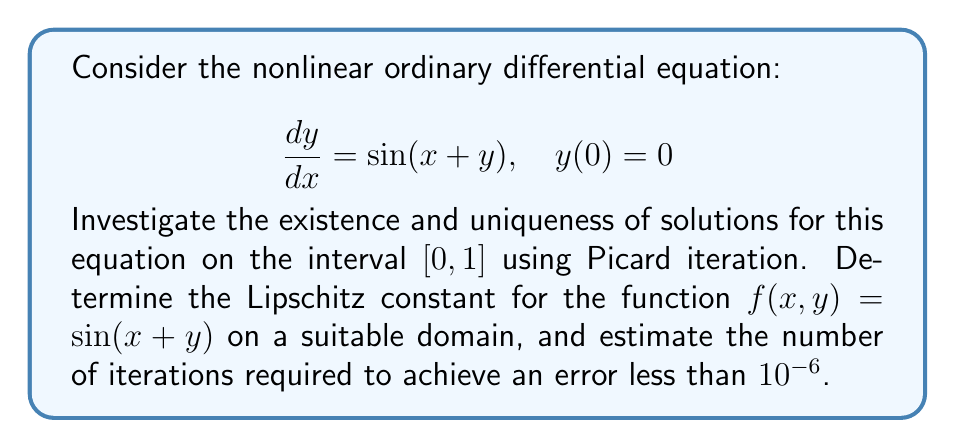Show me your answer to this math problem. To investigate the existence and uniqueness of solutions using Picard iteration, we'll follow these steps:

1) First, we need to verify that the function $f(x,y) = \sin(x+y)$ satisfies the Lipschitz condition on a suitable domain.

2) We'll determine the Lipschitz constant L.

3) We'll use the Picard-Lindelöf theorem to prove existence and uniqueness.

4) Finally, we'll estimate the number of iterations required for a given error bound.

Step 1: Verifying the Lipschitz condition

The function $f(x,y) = \sin(x+y)$ is continuously differentiable, which implies it's Lipschitz continuous on any bounded domain. Let's consider the domain $D = \{(x,y) : 0 \leq x \leq 1, |y| \leq 1\}$.

Step 2: Determining the Lipschitz constant

For $f(x,y) = \sin(x+y)$, we have:

$$\left|\frac{\partial f}{\partial y}\right| = |\cos(x+y)| \leq 1$$

Therefore, we can choose $L = 1$ as our Lipschitz constant on D.

Step 3: Applying the Picard-Lindelöf theorem

The Picard-Lindelöf theorem states that if $f(x,y)$ is continuous on a rectangle containing $(x_0, y_0)$ and satisfies a Lipschitz condition with respect to $y$, then there exists a unique solution to the initial value problem in some interval around $x_0$.

In our case, $f(x,y) = \sin(x+y)$ is continuous on D and satisfies the Lipschitz condition with $L = 1$. Therefore, a unique solution exists on $[0, 1]$.

Step 4: Estimating the number of iterations

The error after n iterations of Picard iteration is bounded by:

$$|y_n(x) - y(x)| \leq \frac{M(e^{L(x-x_0)} - 1)}{L} \cdot \frac{(L(x-x_0))^n}{n!}$$

where M is the maximum value of $|f(x,y)|$ on D.

In our case, $M = 1$ (since $|\sin(x+y)| \leq 1$), $L = 1$, $x_0 = 0$, and we want $x = 1$.

Substituting these values:

$$|y_n(1) - y(1)| \leq (e-1) \cdot \frac{1}{n!}$$

We want this error to be less than $10^{-6}$. So we need to find n such that:

$$(e-1) \cdot \frac{1}{n!} < 10^{-6}$$

Solving this numerically, we find that $n = 13$ is sufficient.
Answer: A unique solution exists on $[0, 1]$. The Lipschitz constant is $L = 1$. At least 13 iterations of Picard iteration are required to achieve an error less than $10^{-6}$. 